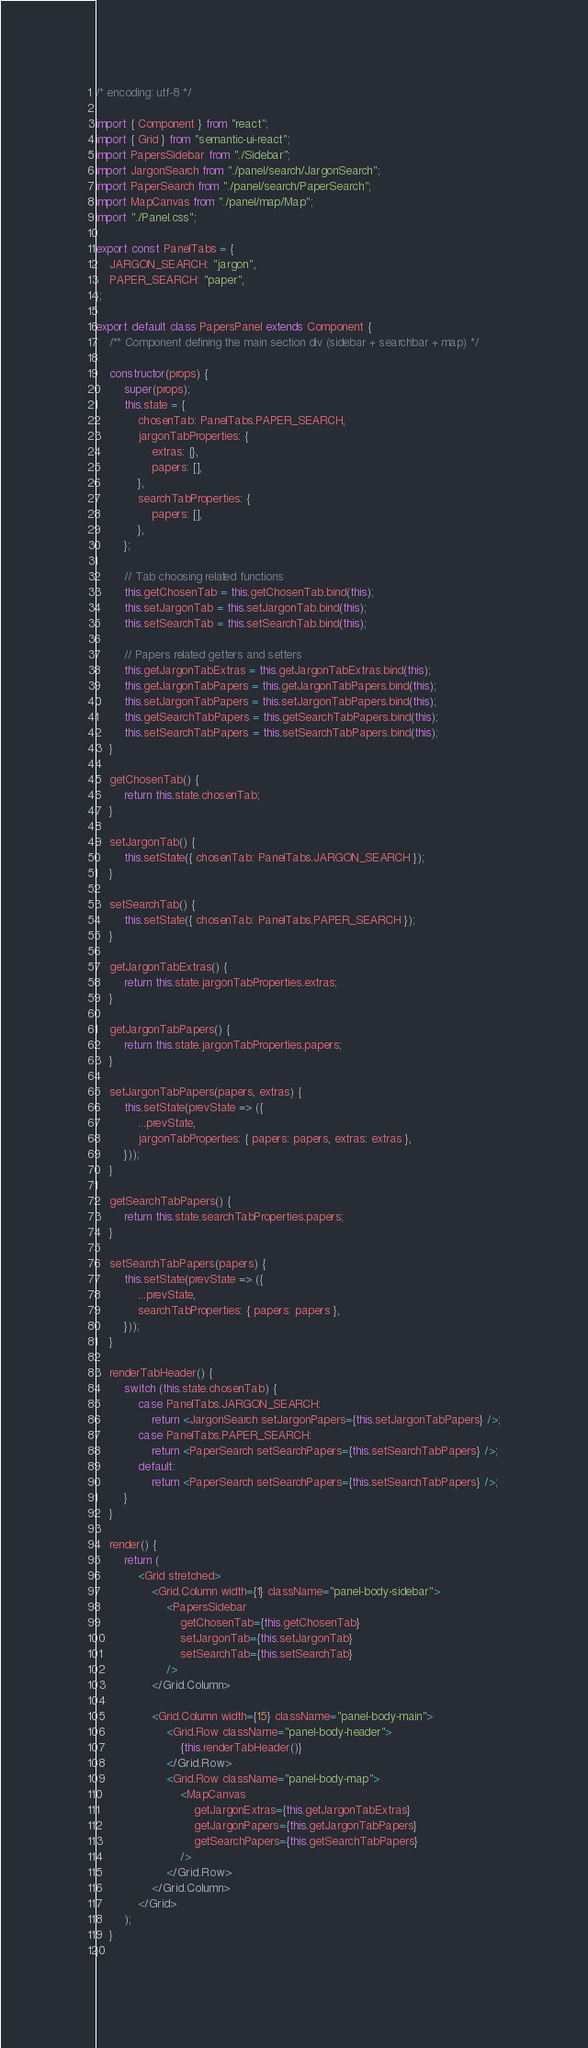Convert code to text. <code><loc_0><loc_0><loc_500><loc_500><_JavaScript_>/* encoding: utf-8 */

import { Component } from "react";
import { Grid } from "semantic-ui-react";
import PapersSidebar from "./Sidebar";
import JargonSearch from "./panel/search/JargonSearch";
import PaperSearch from "./panel/search/PaperSearch";
import MapCanvas from "./panel/map/Map";
import "./Panel.css";

export const PanelTabs = {
    JARGON_SEARCH: "jargon",
    PAPER_SEARCH: "paper",
};

export default class PapersPanel extends Component {
    /** Component defining the main section div (sidebar + searchbar + map) */

    constructor(props) {
        super(props);
        this.state = {
            chosenTab: PanelTabs.PAPER_SEARCH,
            jargonTabProperties: {
                extras: {},
                papers: [],
            },
            searchTabProperties: {
                papers: [],
            },
        };

        // Tab choosing related functions
        this.getChosenTab = this.getChosenTab.bind(this);
        this.setJargonTab = this.setJargonTab.bind(this);
        this.setSearchTab = this.setSearchTab.bind(this);

        // Papers related getters and setters
        this.getJargonTabExtras = this.getJargonTabExtras.bind(this);
        this.getJargonTabPapers = this.getJargonTabPapers.bind(this);
        this.setJargonTabPapers = this.setJargonTabPapers.bind(this);
        this.getSearchTabPapers = this.getSearchTabPapers.bind(this);
        this.setSearchTabPapers = this.setSearchTabPapers.bind(this);
    }

    getChosenTab() {
        return this.state.chosenTab;
    }

    setJargonTab() {
        this.setState({ chosenTab: PanelTabs.JARGON_SEARCH });
    }

    setSearchTab() {
        this.setState({ chosenTab: PanelTabs.PAPER_SEARCH });
    }

    getJargonTabExtras() {
        return this.state.jargonTabProperties.extras;
    }

    getJargonTabPapers() {
        return this.state.jargonTabProperties.papers;
    }

    setJargonTabPapers(papers, extras) {
        this.setState(prevState => ({
            ...prevState,
            jargonTabProperties: { papers: papers, extras: extras },
        }));
    }

    getSearchTabPapers() {
        return this.state.searchTabProperties.papers;
    }

    setSearchTabPapers(papers) {
        this.setState(prevState => ({
            ...prevState,
            searchTabProperties: { papers: papers },
        }));
    }

    renderTabHeader() {
        switch (this.state.chosenTab) {
            case PanelTabs.JARGON_SEARCH:
                return <JargonSearch setJargonPapers={this.setJargonTabPapers} />;
            case PanelTabs.PAPER_SEARCH:
                return <PaperSearch setSearchPapers={this.setSearchTabPapers} />;
            default:
                return <PaperSearch setSearchPapers={this.setSearchTabPapers} />;
        }
    }

    render() {
        return (
            <Grid stretched>
                <Grid.Column width={1} className="panel-body-sidebar">
                    <PapersSidebar
                        getChosenTab={this.getChosenTab}
                        setJargonTab={this.setJargonTab}
                        setSearchTab={this.setSearchTab}
                    />
                </Grid.Column>

                <Grid.Column width={15} className="panel-body-main">
                    <Grid.Row className="panel-body-header">
                        {this.renderTabHeader()}
                    </Grid.Row>
                    <Grid.Row className="panel-body-map">
                        <MapCanvas
                            getJargonExtras={this.getJargonTabExtras}
                            getJargonPapers={this.getJargonTabPapers}
                            getSearchPapers={this.getSearchTabPapers}
                        />
                    </Grid.Row>
                </Grid.Column>
            </Grid>
        );
    }
}
</code> 